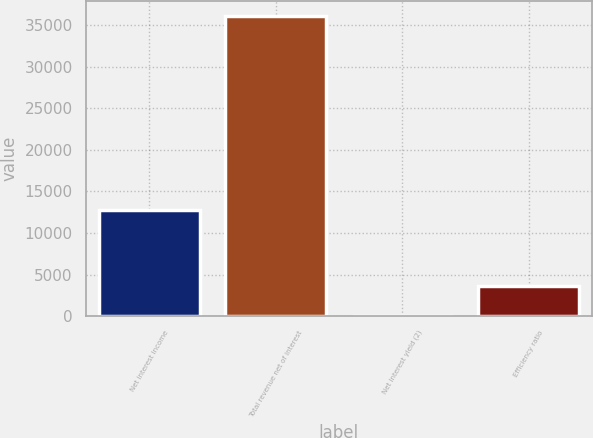Convert chart to OTSL. <chart><loc_0><loc_0><loc_500><loc_500><bar_chart><fcel>Net interest income<fcel>Total revenue net of interest<fcel>Net interest yield (2)<fcel>Efficiency ratio<nl><fcel>12819<fcel>36080<fcel>2.7<fcel>3610.43<nl></chart> 